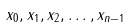<formula> <loc_0><loc_0><loc_500><loc_500>x _ { 0 } , x _ { 1 } , x _ { 2 } , \dots , x _ { n - 1 }</formula> 